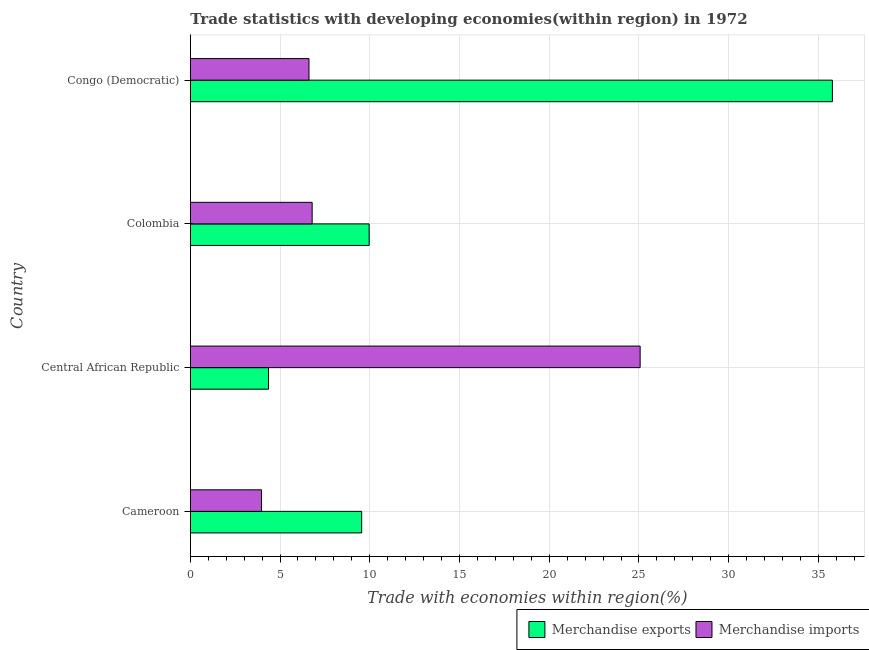How many different coloured bars are there?
Your response must be concise. 2. How many groups of bars are there?
Keep it short and to the point. 4. Are the number of bars per tick equal to the number of legend labels?
Your answer should be very brief. Yes. How many bars are there on the 2nd tick from the bottom?
Ensure brevity in your answer.  2. What is the label of the 2nd group of bars from the top?
Provide a short and direct response. Colombia. In how many cases, is the number of bars for a given country not equal to the number of legend labels?
Give a very brief answer. 0. What is the merchandise imports in Colombia?
Provide a succinct answer. 6.79. Across all countries, what is the maximum merchandise exports?
Make the answer very short. 35.78. Across all countries, what is the minimum merchandise exports?
Your answer should be compact. 4.36. In which country was the merchandise exports maximum?
Offer a very short reply. Congo (Democratic). In which country was the merchandise imports minimum?
Provide a succinct answer. Cameroon. What is the total merchandise imports in the graph?
Your answer should be very brief. 42.44. What is the difference between the merchandise imports in Cameroon and that in Colombia?
Provide a succinct answer. -2.82. What is the difference between the merchandise exports in Colombia and the merchandise imports in Congo (Democratic)?
Provide a short and direct response. 3.35. What is the average merchandise imports per country?
Ensure brevity in your answer.  10.61. What is the difference between the merchandise exports and merchandise imports in Cameroon?
Keep it short and to the point. 5.58. What is the ratio of the merchandise exports in Central African Republic to that in Colombia?
Make the answer very short. 0.44. What is the difference between the highest and the second highest merchandise imports?
Your response must be concise. 18.27. What is the difference between the highest and the lowest merchandise imports?
Offer a terse response. 21.1. Is the sum of the merchandise exports in Central African Republic and Colombia greater than the maximum merchandise imports across all countries?
Offer a very short reply. No. What does the 1st bar from the bottom in Cameroon represents?
Ensure brevity in your answer.  Merchandise exports. How many bars are there?
Your response must be concise. 8. Are the values on the major ticks of X-axis written in scientific E-notation?
Offer a terse response. No. Where does the legend appear in the graph?
Your response must be concise. Bottom right. How are the legend labels stacked?
Your response must be concise. Horizontal. What is the title of the graph?
Keep it short and to the point. Trade statistics with developing economies(within region) in 1972. What is the label or title of the X-axis?
Offer a terse response. Trade with economies within region(%). What is the Trade with economies within region(%) of Merchandise exports in Cameroon?
Provide a short and direct response. 9.55. What is the Trade with economies within region(%) of Merchandise imports in Cameroon?
Your answer should be compact. 3.97. What is the Trade with economies within region(%) of Merchandise exports in Central African Republic?
Provide a short and direct response. 4.36. What is the Trade with economies within region(%) of Merchandise imports in Central African Republic?
Keep it short and to the point. 25.07. What is the Trade with economies within region(%) of Merchandise exports in Colombia?
Your response must be concise. 9.97. What is the Trade with economies within region(%) in Merchandise imports in Colombia?
Give a very brief answer. 6.79. What is the Trade with economies within region(%) of Merchandise exports in Congo (Democratic)?
Make the answer very short. 35.78. What is the Trade with economies within region(%) in Merchandise imports in Congo (Democratic)?
Make the answer very short. 6.61. Across all countries, what is the maximum Trade with economies within region(%) of Merchandise exports?
Offer a very short reply. 35.78. Across all countries, what is the maximum Trade with economies within region(%) in Merchandise imports?
Your answer should be very brief. 25.07. Across all countries, what is the minimum Trade with economies within region(%) of Merchandise exports?
Ensure brevity in your answer.  4.36. Across all countries, what is the minimum Trade with economies within region(%) in Merchandise imports?
Provide a succinct answer. 3.97. What is the total Trade with economies within region(%) of Merchandise exports in the graph?
Offer a very short reply. 59.65. What is the total Trade with economies within region(%) in Merchandise imports in the graph?
Give a very brief answer. 42.44. What is the difference between the Trade with economies within region(%) in Merchandise exports in Cameroon and that in Central African Republic?
Your answer should be compact. 5.19. What is the difference between the Trade with economies within region(%) of Merchandise imports in Cameroon and that in Central African Republic?
Ensure brevity in your answer.  -21.1. What is the difference between the Trade with economies within region(%) of Merchandise exports in Cameroon and that in Colombia?
Keep it short and to the point. -0.42. What is the difference between the Trade with economies within region(%) of Merchandise imports in Cameroon and that in Colombia?
Your answer should be very brief. -2.82. What is the difference between the Trade with economies within region(%) of Merchandise exports in Cameroon and that in Congo (Democratic)?
Ensure brevity in your answer.  -26.23. What is the difference between the Trade with economies within region(%) in Merchandise imports in Cameroon and that in Congo (Democratic)?
Make the answer very short. -2.64. What is the difference between the Trade with economies within region(%) of Merchandise exports in Central African Republic and that in Colombia?
Your answer should be compact. -5.61. What is the difference between the Trade with economies within region(%) of Merchandise imports in Central African Republic and that in Colombia?
Your response must be concise. 18.27. What is the difference between the Trade with economies within region(%) in Merchandise exports in Central African Republic and that in Congo (Democratic)?
Your answer should be compact. -31.42. What is the difference between the Trade with economies within region(%) of Merchandise imports in Central African Republic and that in Congo (Democratic)?
Your answer should be compact. 18.45. What is the difference between the Trade with economies within region(%) of Merchandise exports in Colombia and that in Congo (Democratic)?
Your answer should be compact. -25.81. What is the difference between the Trade with economies within region(%) of Merchandise imports in Colombia and that in Congo (Democratic)?
Give a very brief answer. 0.18. What is the difference between the Trade with economies within region(%) of Merchandise exports in Cameroon and the Trade with economies within region(%) of Merchandise imports in Central African Republic?
Ensure brevity in your answer.  -15.52. What is the difference between the Trade with economies within region(%) of Merchandise exports in Cameroon and the Trade with economies within region(%) of Merchandise imports in Colombia?
Your answer should be compact. 2.76. What is the difference between the Trade with economies within region(%) in Merchandise exports in Cameroon and the Trade with economies within region(%) in Merchandise imports in Congo (Democratic)?
Provide a succinct answer. 2.94. What is the difference between the Trade with economies within region(%) in Merchandise exports in Central African Republic and the Trade with economies within region(%) in Merchandise imports in Colombia?
Offer a terse response. -2.43. What is the difference between the Trade with economies within region(%) of Merchandise exports in Central African Republic and the Trade with economies within region(%) of Merchandise imports in Congo (Democratic)?
Your response must be concise. -2.25. What is the difference between the Trade with economies within region(%) of Merchandise exports in Colombia and the Trade with economies within region(%) of Merchandise imports in Congo (Democratic)?
Provide a short and direct response. 3.35. What is the average Trade with economies within region(%) in Merchandise exports per country?
Make the answer very short. 14.91. What is the average Trade with economies within region(%) in Merchandise imports per country?
Ensure brevity in your answer.  10.61. What is the difference between the Trade with economies within region(%) of Merchandise exports and Trade with economies within region(%) of Merchandise imports in Cameroon?
Ensure brevity in your answer.  5.58. What is the difference between the Trade with economies within region(%) of Merchandise exports and Trade with economies within region(%) of Merchandise imports in Central African Republic?
Your response must be concise. -20.71. What is the difference between the Trade with economies within region(%) in Merchandise exports and Trade with economies within region(%) in Merchandise imports in Colombia?
Ensure brevity in your answer.  3.18. What is the difference between the Trade with economies within region(%) in Merchandise exports and Trade with economies within region(%) in Merchandise imports in Congo (Democratic)?
Your answer should be very brief. 29.16. What is the ratio of the Trade with economies within region(%) in Merchandise exports in Cameroon to that in Central African Republic?
Make the answer very short. 2.19. What is the ratio of the Trade with economies within region(%) of Merchandise imports in Cameroon to that in Central African Republic?
Offer a terse response. 0.16. What is the ratio of the Trade with economies within region(%) of Merchandise exports in Cameroon to that in Colombia?
Offer a terse response. 0.96. What is the ratio of the Trade with economies within region(%) of Merchandise imports in Cameroon to that in Colombia?
Keep it short and to the point. 0.58. What is the ratio of the Trade with economies within region(%) in Merchandise exports in Cameroon to that in Congo (Democratic)?
Ensure brevity in your answer.  0.27. What is the ratio of the Trade with economies within region(%) in Merchandise imports in Cameroon to that in Congo (Democratic)?
Provide a short and direct response. 0.6. What is the ratio of the Trade with economies within region(%) of Merchandise exports in Central African Republic to that in Colombia?
Make the answer very short. 0.44. What is the ratio of the Trade with economies within region(%) of Merchandise imports in Central African Republic to that in Colombia?
Offer a very short reply. 3.69. What is the ratio of the Trade with economies within region(%) of Merchandise exports in Central African Republic to that in Congo (Democratic)?
Your answer should be compact. 0.12. What is the ratio of the Trade with economies within region(%) of Merchandise imports in Central African Republic to that in Congo (Democratic)?
Make the answer very short. 3.79. What is the ratio of the Trade with economies within region(%) in Merchandise exports in Colombia to that in Congo (Democratic)?
Your response must be concise. 0.28. What is the ratio of the Trade with economies within region(%) of Merchandise imports in Colombia to that in Congo (Democratic)?
Ensure brevity in your answer.  1.03. What is the difference between the highest and the second highest Trade with economies within region(%) in Merchandise exports?
Your answer should be compact. 25.81. What is the difference between the highest and the second highest Trade with economies within region(%) in Merchandise imports?
Offer a terse response. 18.27. What is the difference between the highest and the lowest Trade with economies within region(%) of Merchandise exports?
Keep it short and to the point. 31.42. What is the difference between the highest and the lowest Trade with economies within region(%) of Merchandise imports?
Offer a terse response. 21.1. 